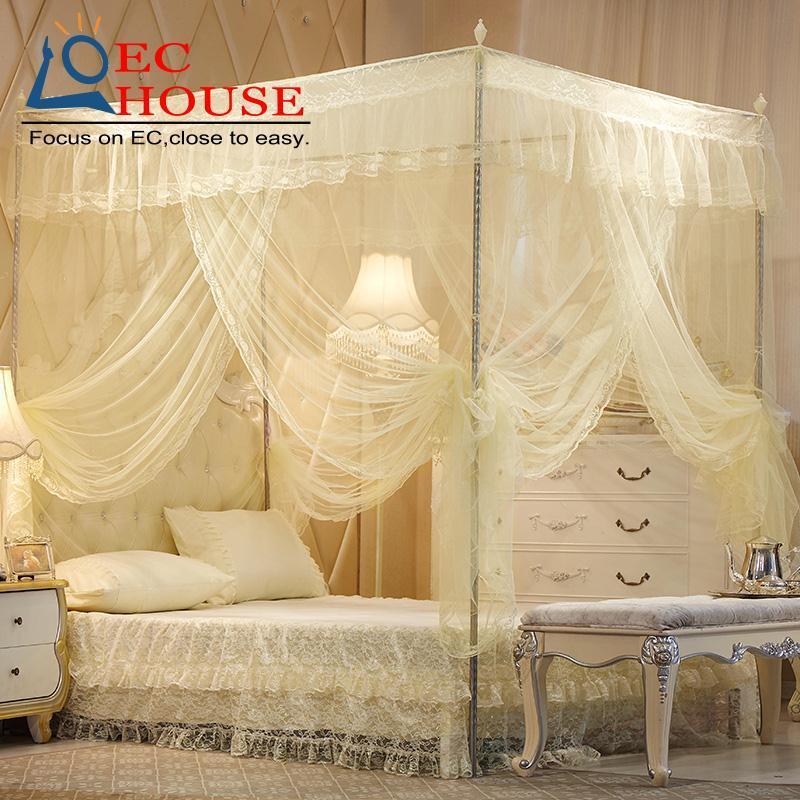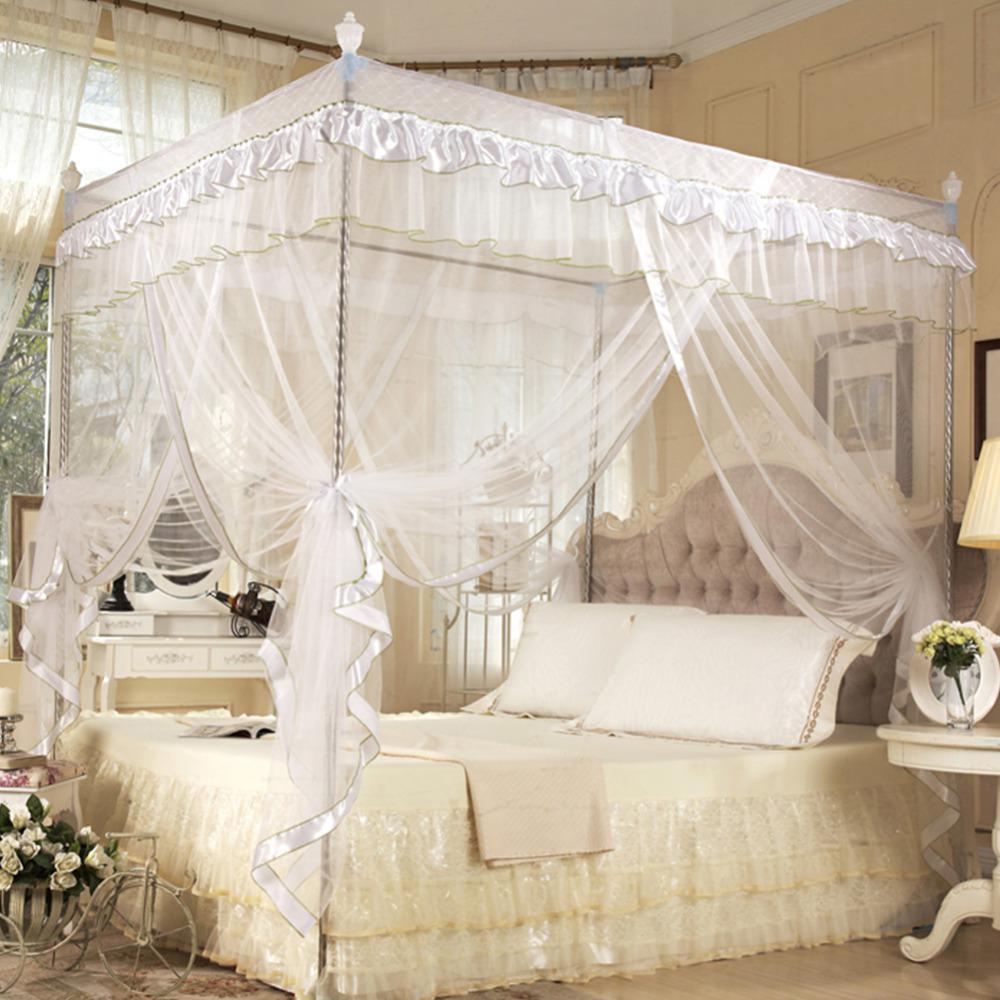The first image is the image on the left, the second image is the image on the right. Assess this claim about the two images: "In each image, a four poster bed is covered with sheer draperies gathered at each post, with a top ruffle and visible knobs at the top of posts.". Correct or not? Answer yes or no. Yes. The first image is the image on the left, the second image is the image on the right. Evaluate the accuracy of this statement regarding the images: "The wall and headboard behind at least one canopy bed feature a tufted, upholstered look.". Is it true? Answer yes or no. Yes. 